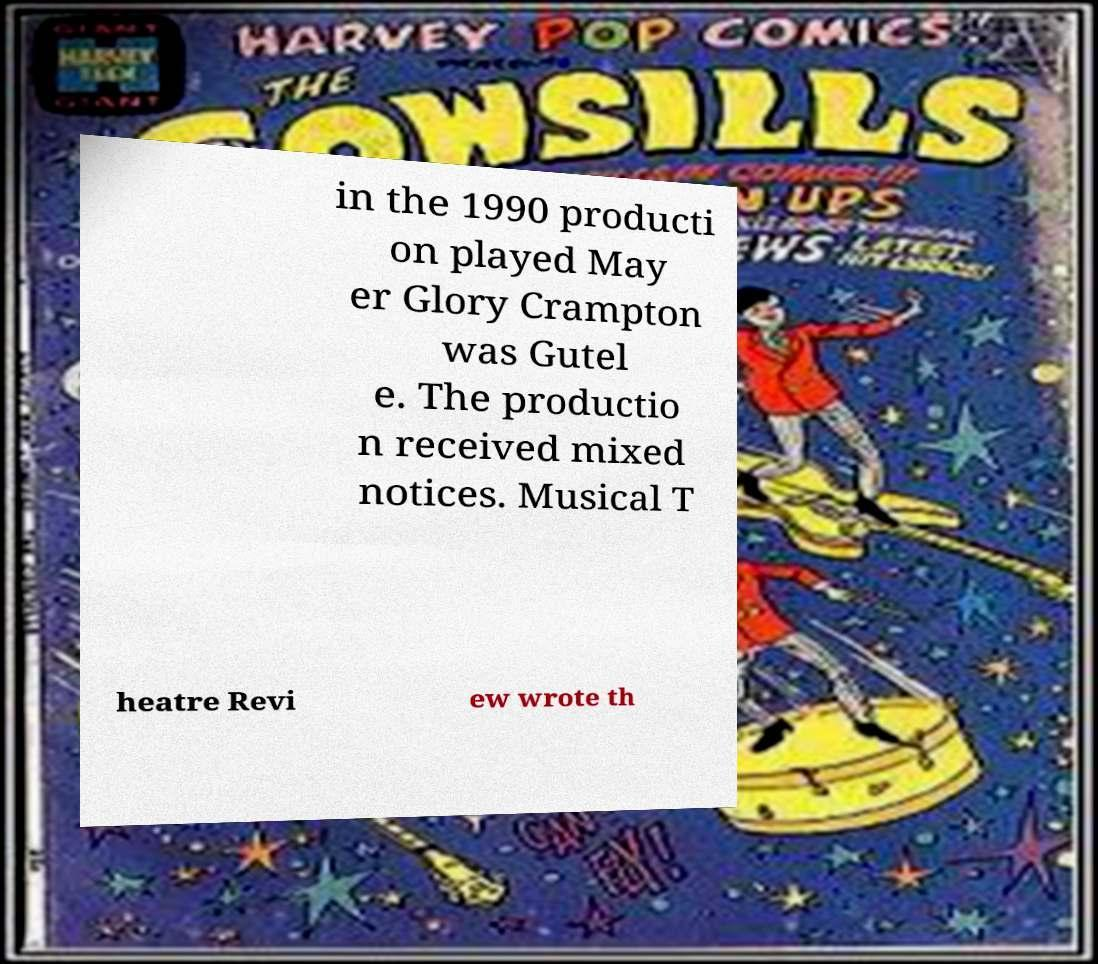I need the written content from this picture converted into text. Can you do that? in the 1990 producti on played May er Glory Crampton was Gutel e. The productio n received mixed notices. Musical T heatre Revi ew wrote th 